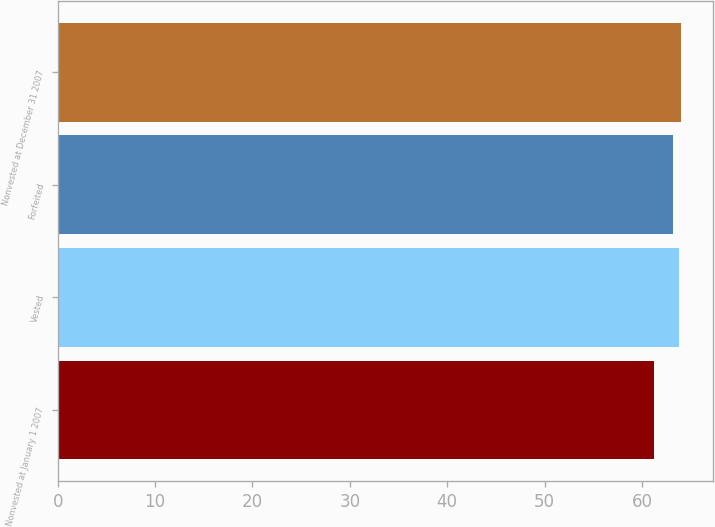<chart> <loc_0><loc_0><loc_500><loc_500><bar_chart><fcel>Nonvested at January 1 2007<fcel>Vested<fcel>Forfeited<fcel>Nonvested at December 31 2007<nl><fcel>61.26<fcel>63.77<fcel>63.23<fcel>64.05<nl></chart> 